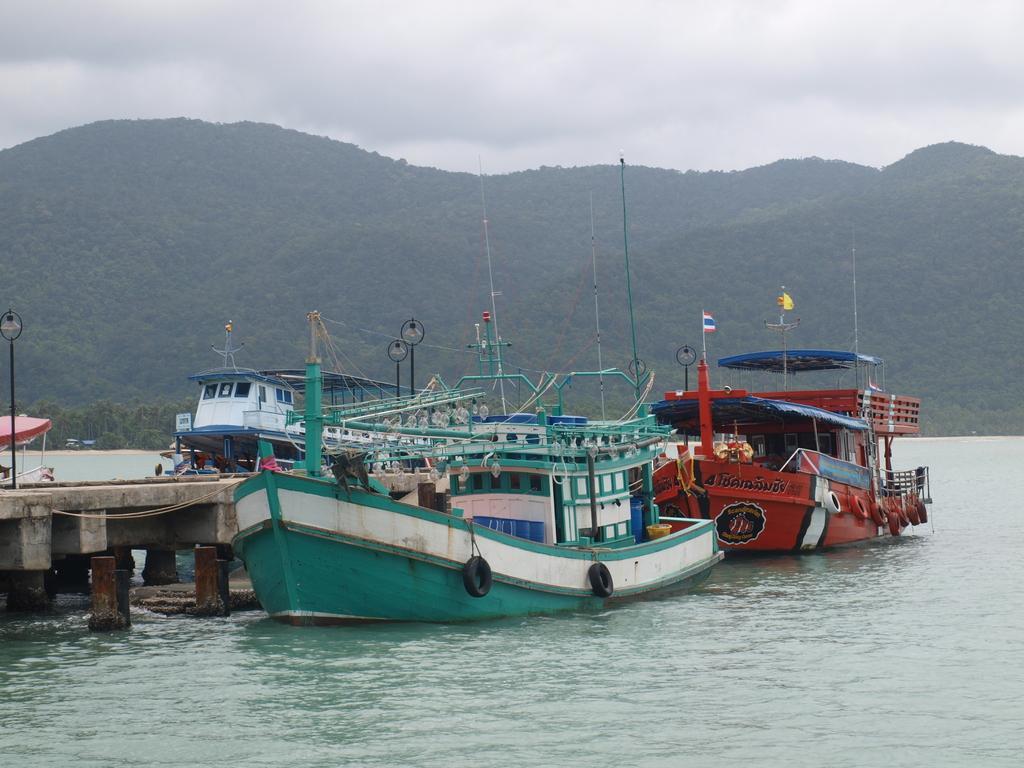Describe this image in one or two sentences. In this picture we can see water at the bottom, there are some boats in the water, on the left side there is a bridge, we can see a pole and a light on the left side, there is a flag in the middle, in the background we can see trees and hills, there is the sky at the top of the picture. 